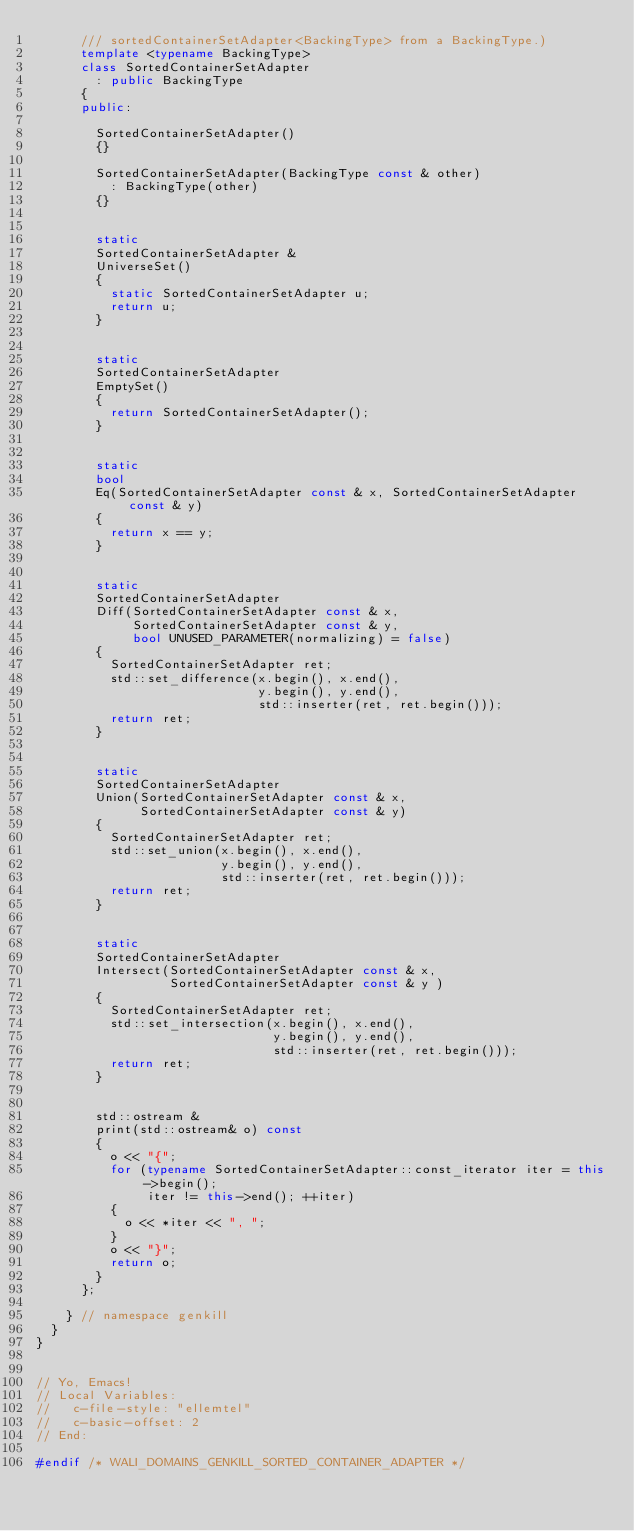Convert code to text. <code><loc_0><loc_0><loc_500><loc_500><_C++_>      /// sortedContainerSetAdapter<BackingType> from a BackingType.)
      template <typename BackingType>
      class SortedContainerSetAdapter
        : public BackingType
      {
      public:
        
        SortedContainerSetAdapter()
        {}

        SortedContainerSetAdapter(BackingType const & other)
          : BackingType(other)
        {}


        static
        SortedContainerSetAdapter &
        UniverseSet()
        {
          static SortedContainerSetAdapter u;
          return u;
        }
    

        static
        SortedContainerSetAdapter
        EmptySet()
        {
          return SortedContainerSetAdapter();
        }
    

        static
        bool
        Eq(SortedContainerSetAdapter const & x, SortedContainerSetAdapter const & y)
        {
          return x == y;
        }


        static
        SortedContainerSetAdapter
        Diff(SortedContainerSetAdapter const & x,
             SortedContainerSetAdapter const & y,
             bool UNUSED_PARAMETER(normalizing) = false)
        {      
          SortedContainerSetAdapter ret;
          std::set_difference(x.begin(), x.end(),
                              y.begin(), y.end(),
                              std::inserter(ret, ret.begin()));
          return ret;
        }
    

        static
        SortedContainerSetAdapter
        Union(SortedContainerSetAdapter const & x,
              SortedContainerSetAdapter const & y)
        {
          SortedContainerSetAdapter ret;
          std::set_union(x.begin(), x.end(),
                         y.begin(), y.end(),
                         std::inserter(ret, ret.begin()));
          return ret;
        }        


        static
        SortedContainerSetAdapter
        Intersect(SortedContainerSetAdapter const & x,
                  SortedContainerSetAdapter const & y )
        {
          SortedContainerSetAdapter ret;
          std::set_intersection(x.begin(), x.end(),
                                y.begin(), y.end(),
                                std::inserter(ret, ret.begin()));
          return ret;
        }        


        std::ostream &
        print(std::ostream& o) const
        {
          o << "{";
          for (typename SortedContainerSetAdapter::const_iterator iter = this->begin();
               iter != this->end(); ++iter)
          {
            o << *iter << ", ";
          }
          o << "}";
          return o;
        }
      };

    } // namespace genkill
  }
}


// Yo, Emacs!
// Local Variables:
//   c-file-style: "ellemtel"
//   c-basic-offset: 2
// End:

#endif /* WALI_DOMAINS_GENKILL_SORTED_CONTAINER_ADAPTER */
</code> 